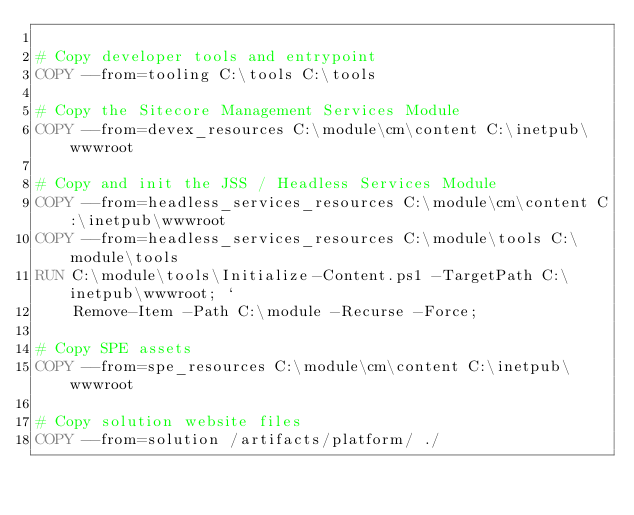<code> <loc_0><loc_0><loc_500><loc_500><_Dockerfile_>
# Copy developer tools and entrypoint
COPY --from=tooling C:\tools C:\tools

# Copy the Sitecore Management Services Module
COPY --from=devex_resources C:\module\cm\content C:\inetpub\wwwroot

# Copy and init the JSS / Headless Services Module
COPY --from=headless_services_resources C:\module\cm\content C:\inetpub\wwwroot
COPY --from=headless_services_resources C:\module\tools C:\module\tools
RUN C:\module\tools\Initialize-Content.ps1 -TargetPath C:\inetpub\wwwroot; `
    Remove-Item -Path C:\module -Recurse -Force;

# Copy SPE assets
COPY --from=spe_resources C:\module\cm\content C:\inetpub\wwwroot

# Copy solution website files
COPY --from=solution /artifacts/platform/ ./</code> 